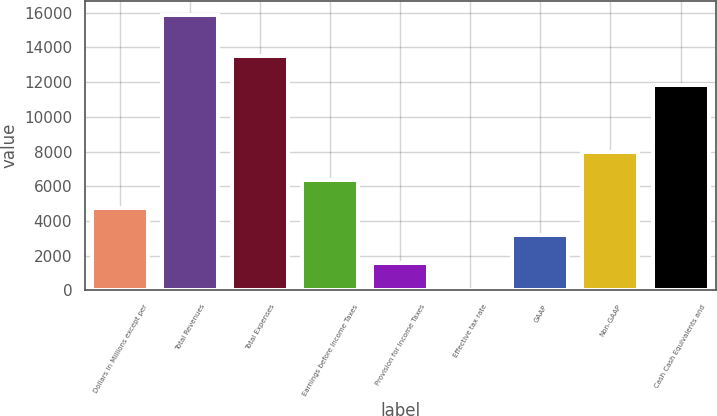Convert chart to OTSL. <chart><loc_0><loc_0><loc_500><loc_500><bar_chart><fcel>Dollars in Millions except per<fcel>Total Revenues<fcel>Total Expenses<fcel>Earnings before Income Taxes<fcel>Provision for Income Taxes<fcel>Effective tax rate<fcel>GAAP<fcel>Non-GAAP<fcel>Cash Cash Equivalents and<nl><fcel>4774.06<fcel>15879<fcel>13498<fcel>6360.48<fcel>1601.22<fcel>14.8<fcel>3187.64<fcel>7946.9<fcel>11843<nl></chart> 